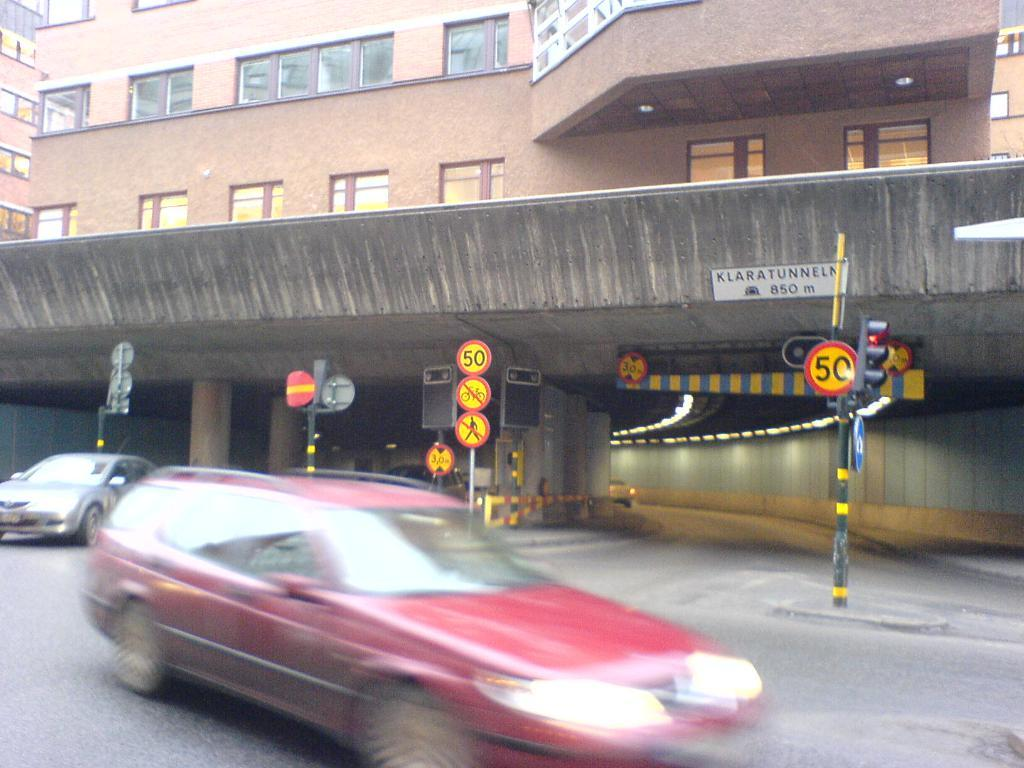What can be seen in the foreground of the image? There are two cars in the foreground of the image. Where are the cars located? The cars are on the road. What other elements can be seen in the image? There are sign boards and a subway road in the image. What is visible in the background of the image? There are buildings visible at the top of the image. What type of breakfast is being served by the giants in the image? There are no giants or breakfast present in the image. 